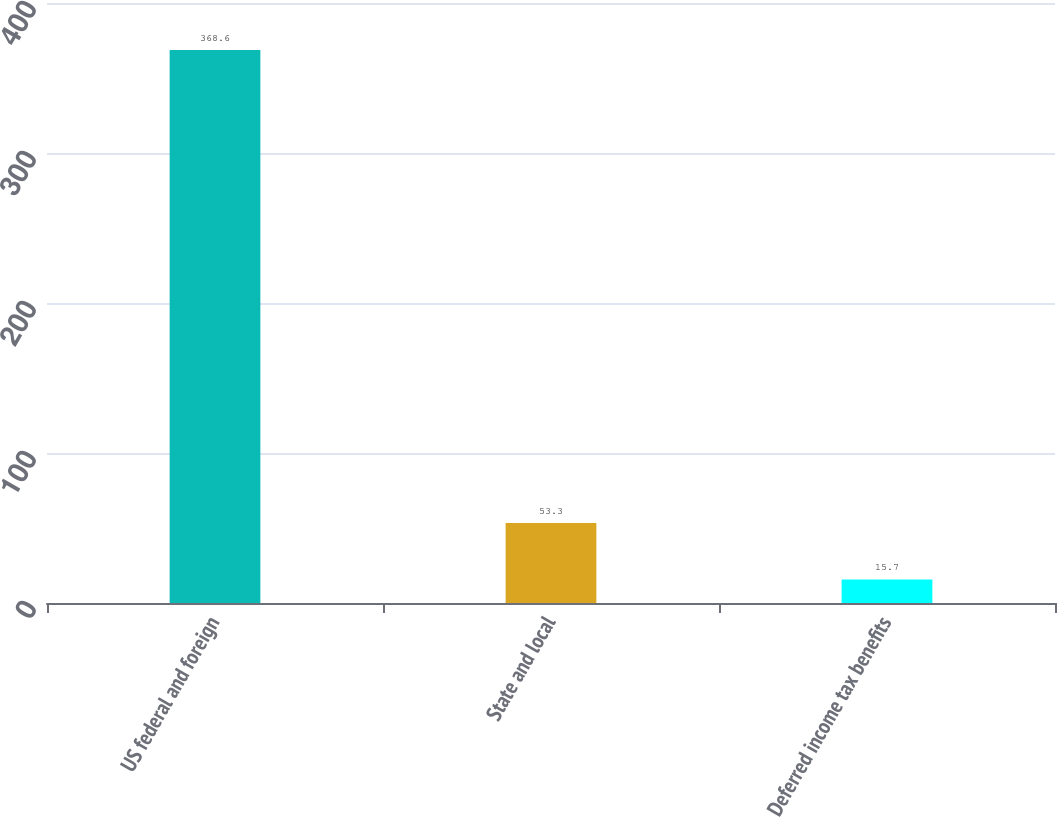Convert chart. <chart><loc_0><loc_0><loc_500><loc_500><bar_chart><fcel>US federal and foreign<fcel>State and local<fcel>Deferred income tax benefits<nl><fcel>368.6<fcel>53.3<fcel>15.7<nl></chart> 